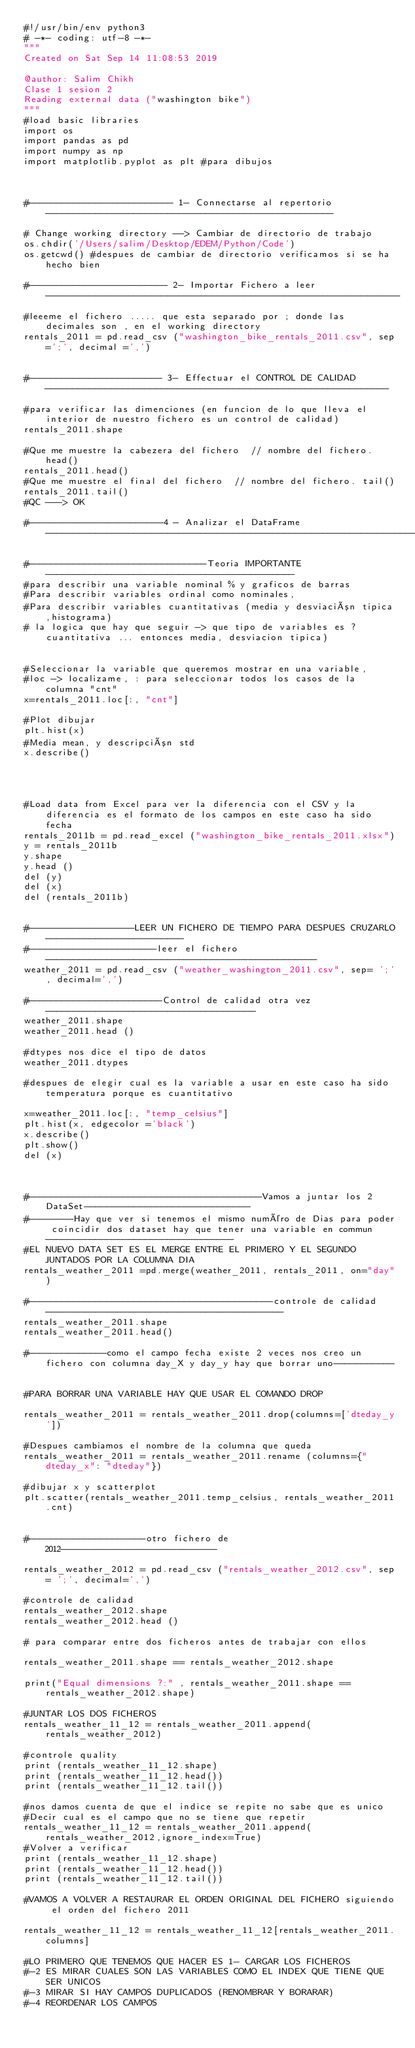Convert code to text. <code><loc_0><loc_0><loc_500><loc_500><_Python_>#!/usr/bin/env python3
# -*- coding: utf-8 -*-
"""
Created on Sat Sep 14 11:08:53 2019

@author: Salim Chikh
Clase 1 sesion 2
Reading external data ("washington bike")
"""
#load basic libraries
import os
import pandas as pd
import numpy as np
import matplotlib.pyplot as plt #para dibujos



#-------------------------- 1- Connectarse al repertorio----------------------------------------------------

# Change working directory --> Cambiar de directorio de trabajo 
os.chdir('/Users/salim/Desktop/EDEM/Python/Code')
os.getcwd() #despues de cambiar de directorio verificamos si se ha hecho bien

#------------------------- 2- Importar Fichero a leer----------------------------------------------------------------
#leeeme el fichero ..... que esta separado por ; donde las decimales son , en el working directory
rentals_2011 = pd.read_csv ("washington_bike_rentals_2011.csv", sep=';', decimal =',')


#------------------------ 3- Effectuar el CONTROL DE CALIDAD --------------------------------------------------------------

#para verificar las dimenciones (en funcion de lo que lleva el interior de nuestro fichero es un control de calidad)
rentals_2011.shape 

#Que me muestre la cabezera del fichero  // nombre del fichero. head()
rentals_2011.head()
#Que me muestre el final del fichero  // nombre del fichero. tail()
rentals_2011.tail()
#QC ---> OK

#------------------------4 - Analizar el DataFrame-------------------------------------------------------------------

#--------------------------------Teoria IMPORTANTE---------------------------------------------
#para describir una variable nominal % y graficos de barras
#Para describir variables ordinal como nominales, 
#Para describir variables cuantitativas (media y desviación tipica,histograma)
# la logica que hay que seguir -> que tipo de variables es ? cuantitativa ... entonces media, desviacion tipica)


#Seleccionar la variable que queremos mostrar en una variable, 
#loc -> localizame, : para seleccionar todos los casos de la columna "cnt" 
x=rentals_2011.loc[:, "cnt"]

#Plot dibujar
plt.hist(x)
#Media mean, y descripción std
x.describe()




#Load data from Excel para ver la diferencia con el CSV y la diferencia es el formato de los campos en este caso ha sido fecha
rentals_2011b = pd.read_excel ("washington_bike_rentals_2011.xlsx")
y = rentals_2011b
y.shape
y.head ()
del (y)
del (x)
del (rentals_2011b)


#-------------------LEER UN FICHERO DE TIEMPO PARA DESPUES CRUZARLO-------------------------
#-----------------------leer el fichero-------------------------------------------------
weather_2011 = pd.read_csv ("weather_washington_2011.csv", sep= ';', decimal=',')

#------------------------Control de calidad otra vez--------------------------------------
weather_2011.shape
weather_2011.head ()

#dtypes nos dice el tipo de datos
weather_2011.dtypes

#despues de elegir cual es la variable a usar en este caso ha sido temperatura porque es cuantitativo 

x=weather_2011.loc[:, "temp_celsius"]
plt.hist(x, edgecolor ='black')
x.describe()
plt.show()
del (x)



#------------------------------------------Vamos a juntar los 2 DataSet------------------------------
#--------Hay que ver si tenemos el mismo numéro de Dias para poder coincidir dos dataset hay que tener una variable en commun----------------------------------
#EL NUEVO DATA SET ES EL MERGE ENTRE EL PRIMERO Y EL SEGUNDO JUNTADOS POR LA COLUMNA DIA
rentals_weather_2011 =pd.merge(weather_2011, rentals_2011, on="day")

#--------------------------------------------controle de calidad-------------------------------------------
rentals_weather_2011.shape
rentals_weather_2011.head()

#--------------como el campo fecha existe 2 veces nos creo un fichero con columna day_X y day_y hay que borrar uno-----------


#PARA BORRAR UNA VARIABLE HAY QUE USAR EL COMANDO DROP 

rentals_weather_2011 = rentals_weather_2011.drop(columns=['dteday_y'])

#Despues cambiamos el nombre de la columna que queda 
rentals_weather_2011 = rentals_weather_2011.rename (columns={"dteday_x": "dteday"})

#dibujar x y scatterplot 
plt.scatter(rentals_weather_2011.temp_celsius, rentals_weather_2011.cnt)


#---------------------otro fichero de 2012---------------------------

rentals_weather_2012 = pd.read_csv ("rentals_weather_2012.csv", sep= ';', decimal=',')

#controle de calidad
rentals_weather_2012.shape
rentals_weather_2012.head ()

# para comparar entre dos ficheros antes de trabajar con ellos 

rentals_weather_2011.shape == rentals_weather_2012.shape

print("Equal dimensions ?:" , rentals_weather_2011.shape == rentals_weather_2012.shape)

#JUNTAR LOS DOS FICHEROS
rentals_weather_11_12 = rentals_weather_2011.append(rentals_weather_2012)

#controle quality
print (rentals_weather_11_12.shape)
print (rentals_weather_11_12.head())
print (rentals_weather_11_12.tail())

#nos damos cuenta de que el indice se repite no sabe que es unico
#Decir cual es el campo que no se tiene que repetir
rentals_weather_11_12 = rentals_weather_2011.append(rentals_weather_2012,ignore_index=True)
#Volver a verificar 
print (rentals_weather_11_12.shape)
print (rentals_weather_11_12.head())
print (rentals_weather_11_12.tail())

#VAMOS A VOLVER A RESTAURAR EL ORDEN ORIGINAL DEL FICHERO siguiendo el orden del fichero 2011

rentals_weather_11_12 = rentals_weather_11_12[rentals_weather_2011.columns]

#LO PRIMERO QUE TENEMOS QUE HACER ES 1- CARGAR LOS FICHEROS 
#-2 ES MIRAR CUALES SON LAS VARIABLES COMO EL INDEX QUE TIENE QUE SER UNICOS 
#-3 MIRAR SI HAY CAMPOS DUPLICADOS (RENOMBRAR Y BORARAR)
#-4 REORDENAR LOS CAMPOS 

</code> 